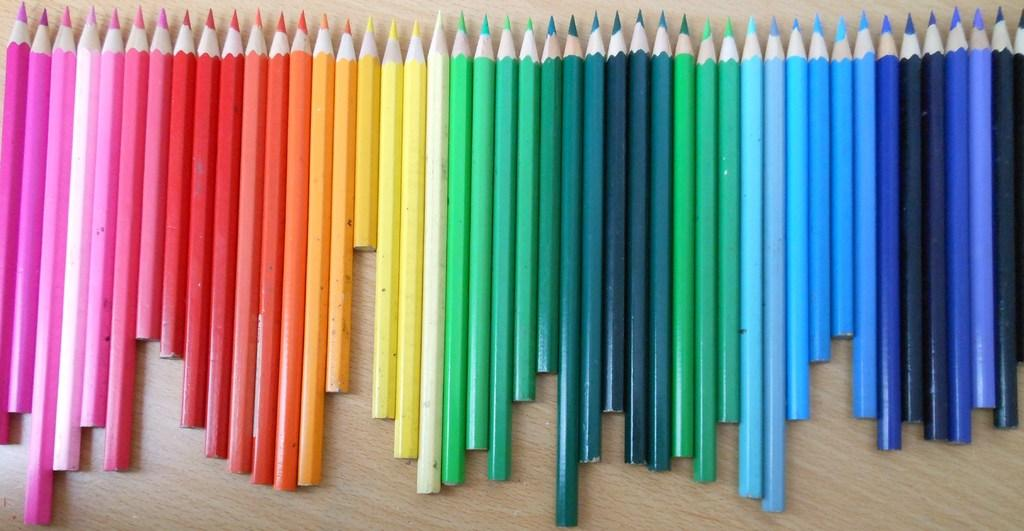What objects are visible in the image? There are color pencils in the image. Where are the color pencils located? The color pencils are on a table. What type of street can be seen in the image? There is no street present in the image; it only features color pencils on a table. 